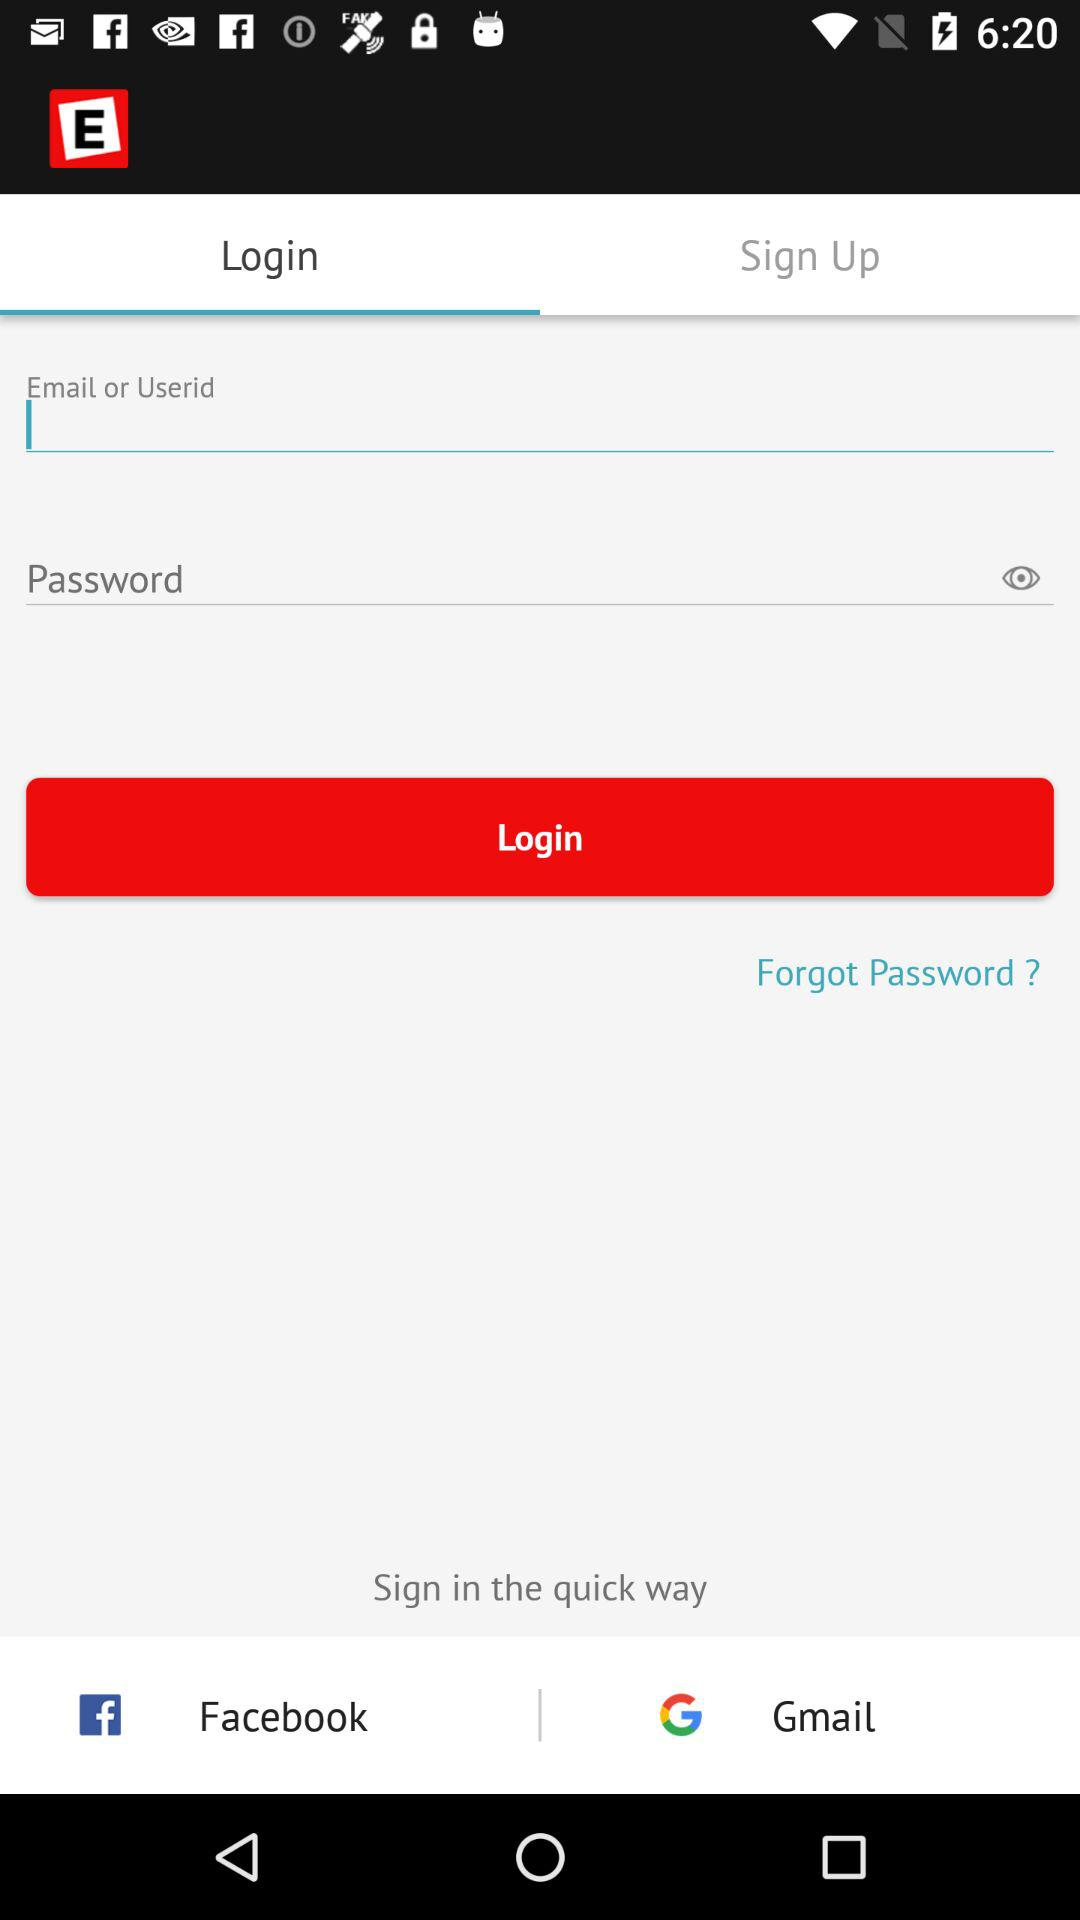How many fields are required to login to the account?
Answer the question using a single word or phrase. 2 